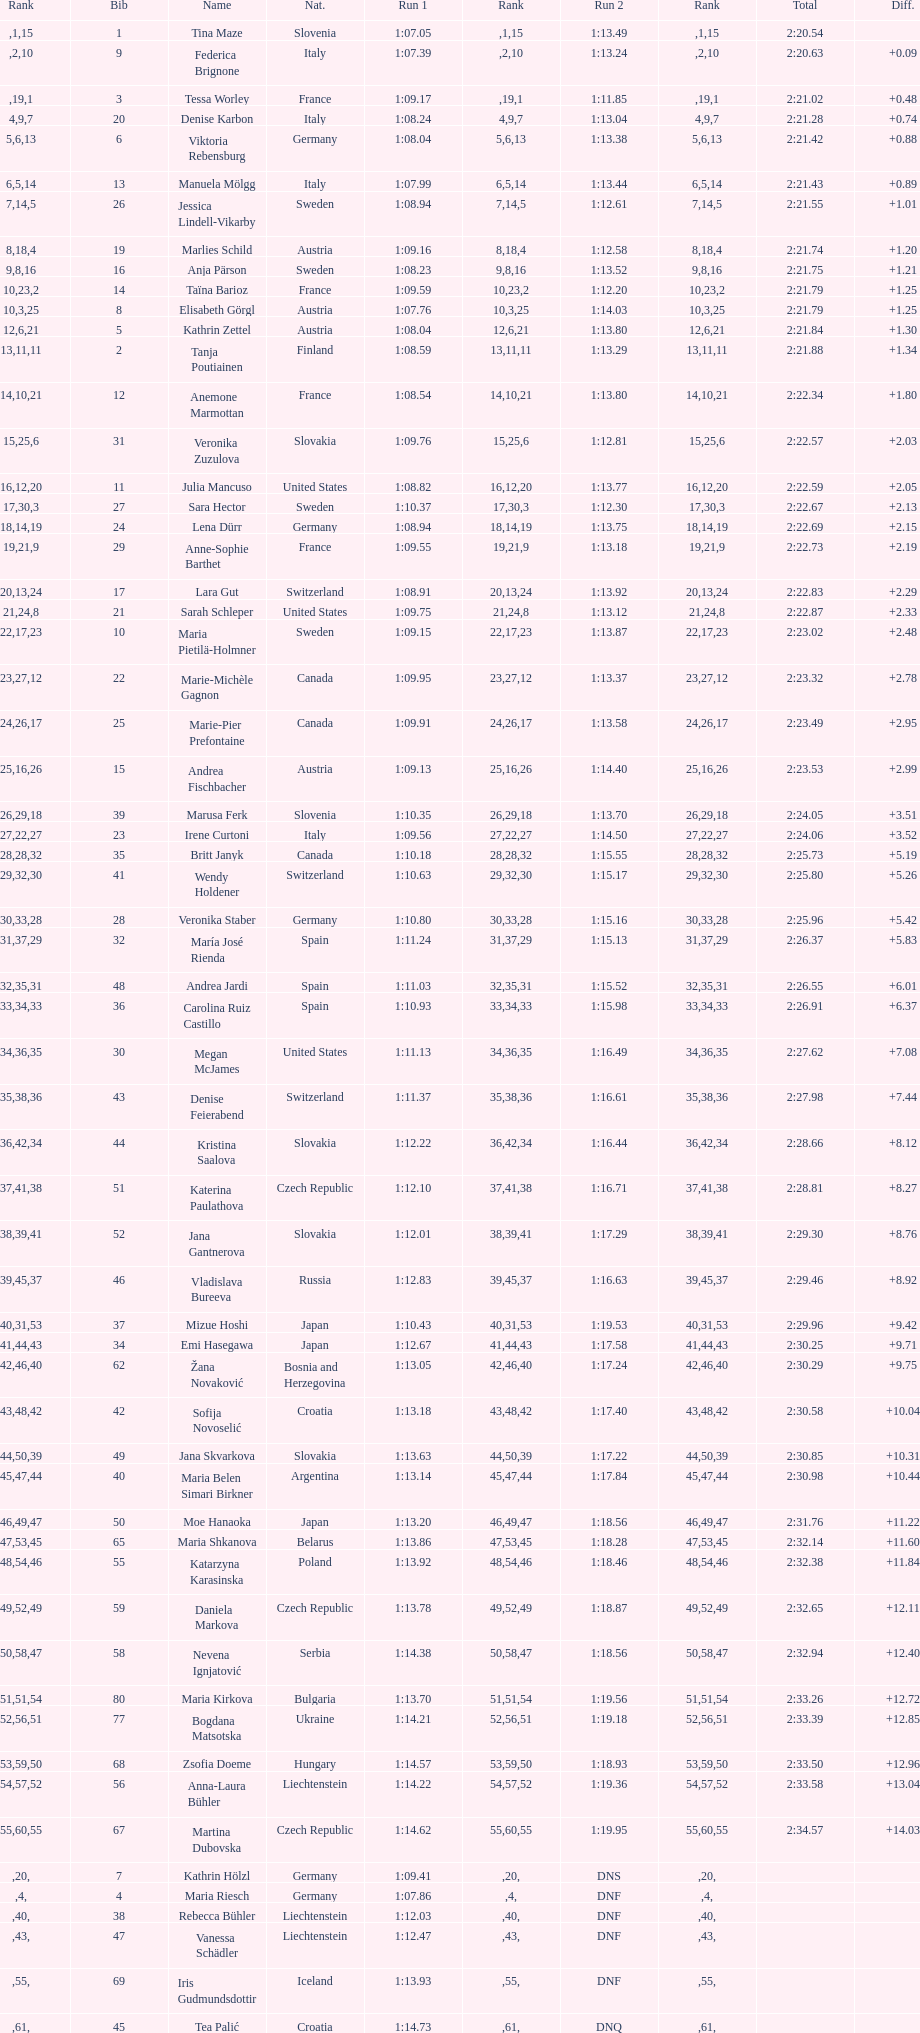What is the name before anja parson? Marlies Schild. 